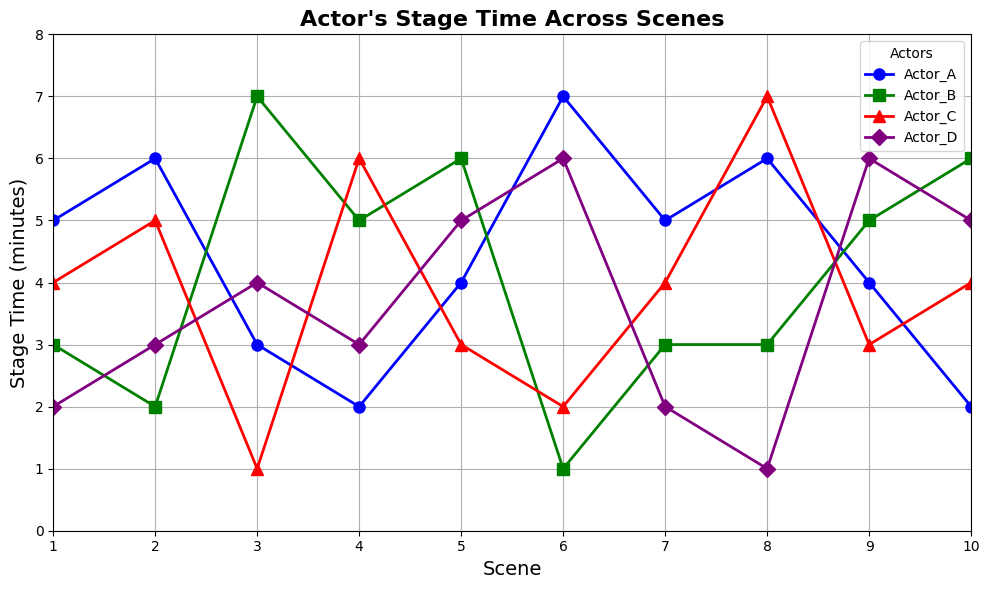What's the total stage time for Actor_C in all scenes? To find the total stage time for Actor_C, sum up their stage times across all scenes: 4 + 5 + 1 + 6 + 3 + 2 + 4 + 7 + 3 + 4 = 39
Answer: 39 In which scene does Actor_B have the least stage time? By examining the stage times of Actor_B across all scenes, we identify that Actor_B has the least stage time of 1 minute in scene 6.
Answer: Scene 6 How does Actor_D's stage time compare between Scene 1 and Scene 4? In Scene 1, Actor_D's stage time is 2 minutes. In Scene 4, it is 3 minutes. Therefore, Actor_D's stage time in Scene 4 is greater than in Scene 1 by 1 minute.
Answer: Greater by 1 minute What's the combined stage time for Actor_A and Actor_D in Scene 7? For Scene 7, Actor_A's stage time is 5 minutes and Actor_D's stage time is 2 minutes. Adding these together gives 5 + 2 = 7 minutes.
Answer: 7 minutes Which actor has the most fluctuating stage time across scenes? By observing the plot, it's evident that Actor_B's stage time varies significantly across scenes, indicating the most fluctuating stage time.
Answer: Actor_B What's the average stage time of actors in Scene 5? To find the average stage time, sum the stage times of all actors in Scene 5: 4 (Actor_A) + 6 (Actor_B) + 3 (Actor_C) + 5 (Actor_D) = 18. The average is 18 / 4 = 4.5 minutes.
Answer: 4.5 minutes In which scenes do Actor_A and Actor_C have exactly the same stage time? By checking the plot, both Actor_A and Actor_C have the same stage time in Scene 1 (4 minutes) and Scene 7 (5 minutes).
Answer: Scene 1 and Scene 7 What is the difference in stage time between Actor_A and Actor_B in Scene 2? In Scene 2, Actor_A has a stage time of 6 minutes, and Actor_B has 2 minutes. The difference is 6 - 2 = 4 minutes.
Answer: 4 minutes In which scene does Actor_C have the highest stage time? By looking at the plot, Actor_C has the highest stage time of 7 minutes in Scene 8.
Answer: Scene 8 How many scenes feature a stage time greater than 5 minutes for Actor_A? Checking Actor_A's stage times: Scene 2 (6 min), Scene 6 (7 min), and Scene 8 (6 min) are greater than 5 minutes. That's a total of 3 scenes.
Answer: 3 scenes 